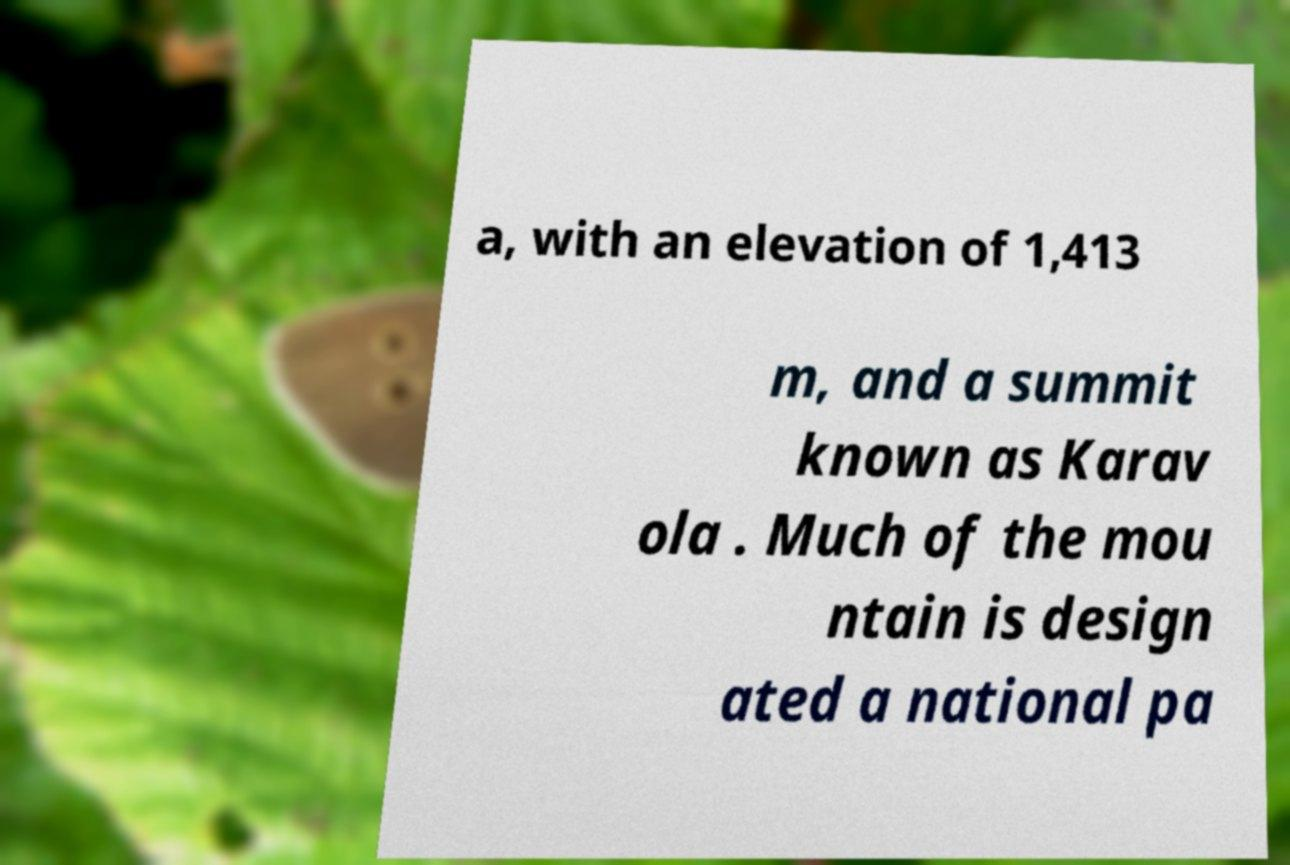For documentation purposes, I need the text within this image transcribed. Could you provide that? a, with an elevation of 1,413 m, and a summit known as Karav ola . Much of the mou ntain is design ated a national pa 